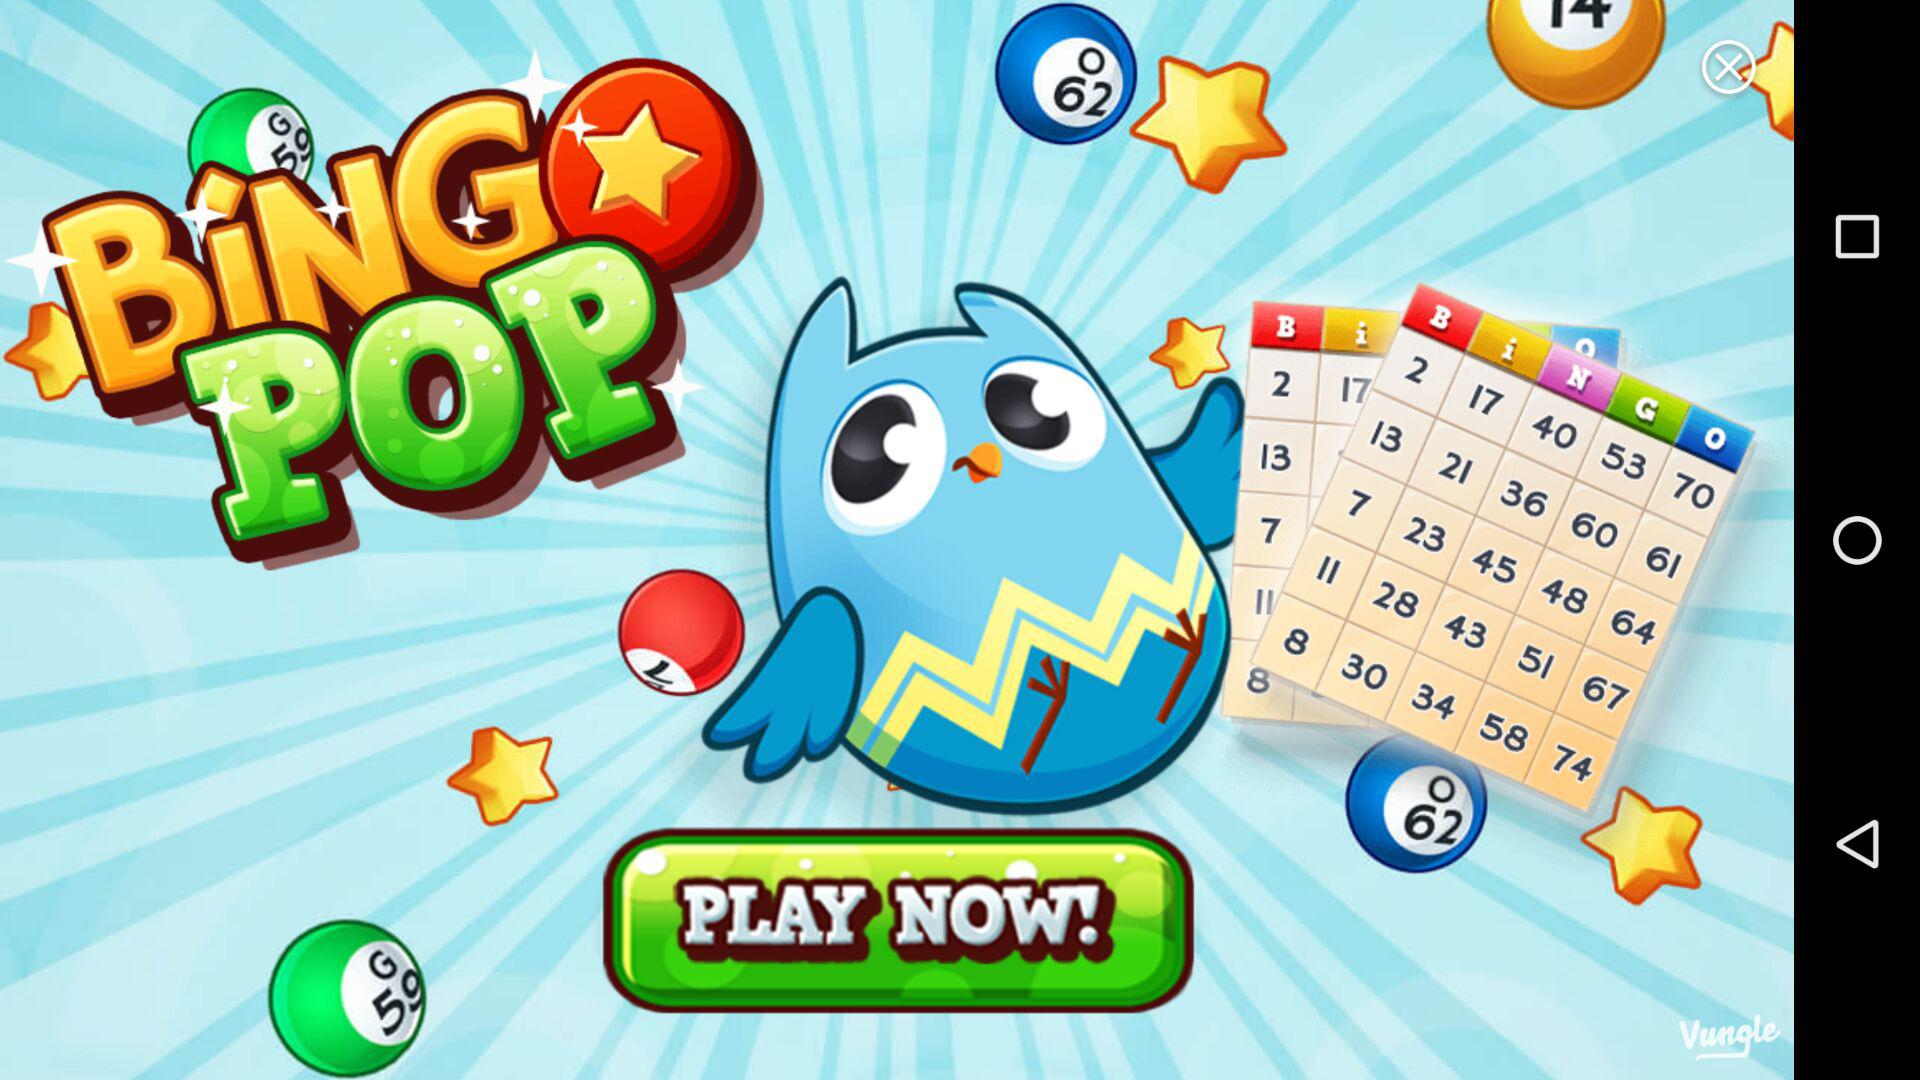How much more is the reward for day 5 than day 1?
Answer the question using a single word or phrase. 25 